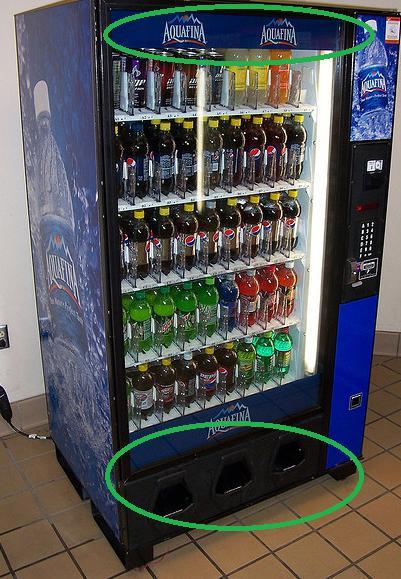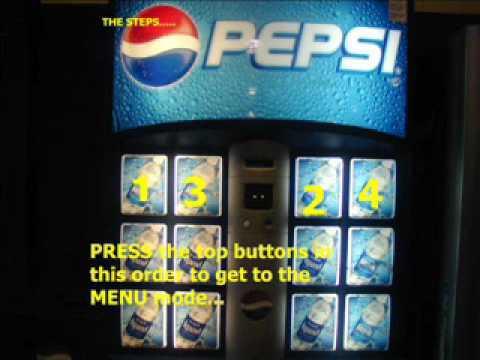The first image is the image on the left, the second image is the image on the right. Analyze the images presented: Is the assertion "All images only show beverages." valid? Answer yes or no. Yes. 